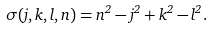<formula> <loc_0><loc_0><loc_500><loc_500>\sigma ( j , k , l , n ) = n ^ { 2 } - j ^ { 2 } + k ^ { 2 } - l ^ { 2 } .</formula> 